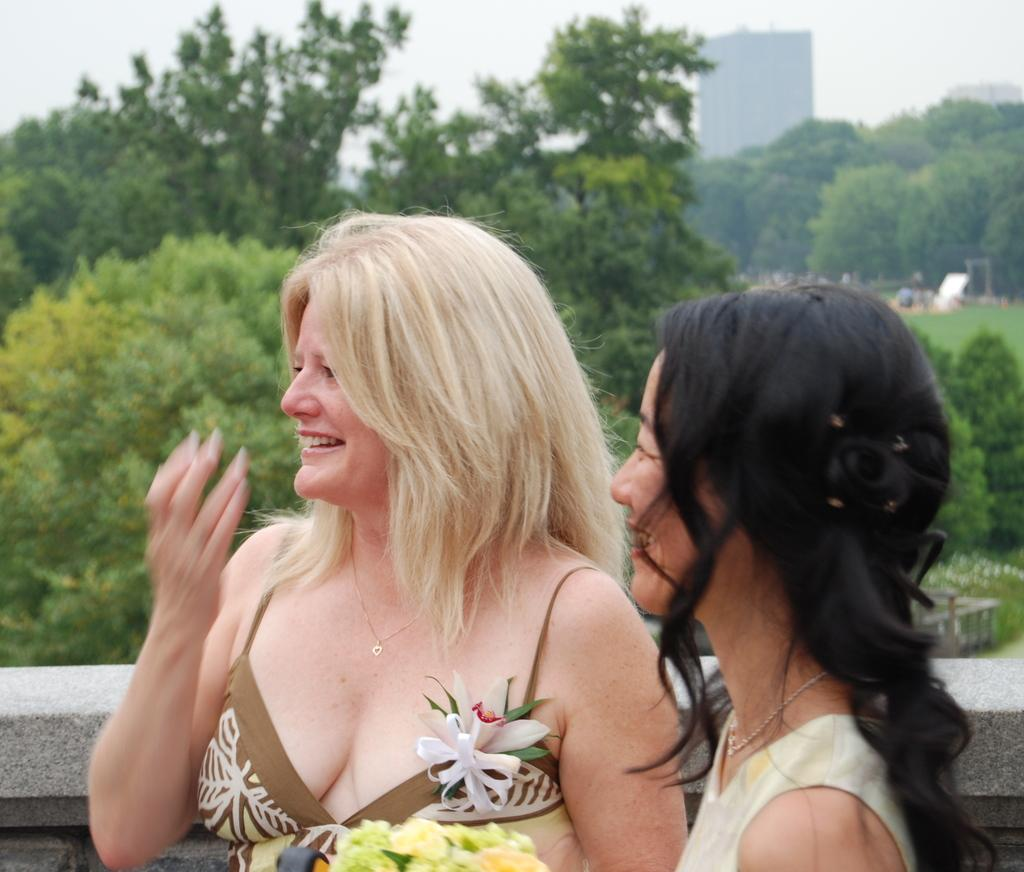How many women are in the image? There are two women standing in the front of the image. What can be seen behind the women? There is a wall visible in the image. What type of natural environment is present in the image? Grass and trees are present in the image. What type of structure is visible in the image? There is a building in the image. What is visible in the background of the image? The sky is visible in the image. Reasoning: Let'ing: Let's think step by step in order to produce the conversation. We start by identifying the main subjects in the image, which are the two women. Then, we describe the background and surroundings, including the wall, grass, trees, building, and sky. Each question is designed to elicit a specific detail about the image that is known from the provided facts. Absurd Question/Answer: What type of stove is visible in the image? There is no stove present in the image. Is there a judge standing next to the women in the image? There is no judge visible in the image. What type of airport is visible in the image? There is no airport present in the image. Is there a stove standing next to the women in the image? There is no stove visible in the image. 